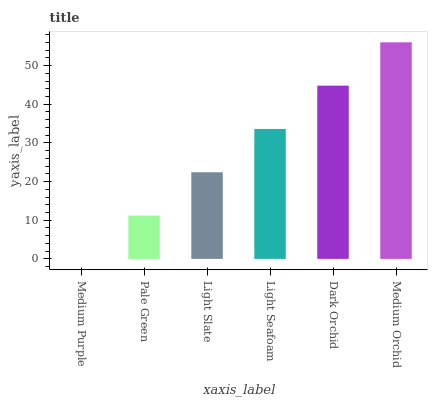Is Medium Purple the minimum?
Answer yes or no. Yes. Is Medium Orchid the maximum?
Answer yes or no. Yes. Is Pale Green the minimum?
Answer yes or no. No. Is Pale Green the maximum?
Answer yes or no. No. Is Pale Green greater than Medium Purple?
Answer yes or no. Yes. Is Medium Purple less than Pale Green?
Answer yes or no. Yes. Is Medium Purple greater than Pale Green?
Answer yes or no. No. Is Pale Green less than Medium Purple?
Answer yes or no. No. Is Light Seafoam the high median?
Answer yes or no. Yes. Is Light Slate the low median?
Answer yes or no. Yes. Is Pale Green the high median?
Answer yes or no. No. Is Light Seafoam the low median?
Answer yes or no. No. 